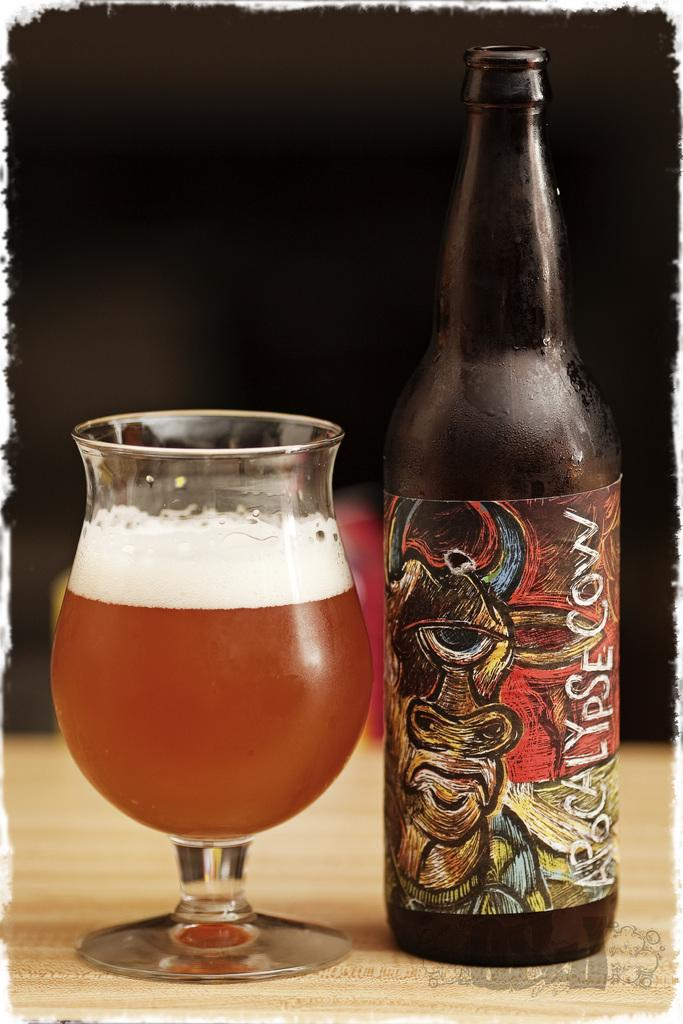What is in the glass that is visible in the image? There is a drink in the glass in the image. What can be seen on the bottle in the image? There is a label on the bottle in the image. Where are the glass and bottle placed in the image? The glass and bottle are placed on a wooden surface in the image. What is the color of the background in the image? The background of the image is dark. How does the wind affect the balance of the glass and bottle in the image? There is no wind present in the image, so it cannot affect the balance of the glass and bottle. 